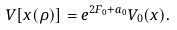<formula> <loc_0><loc_0><loc_500><loc_500>V [ x ( \rho ) ] = e ^ { 2 F _ { 0 } + a _ { 0 } } V _ { 0 } ( x ) .</formula> 